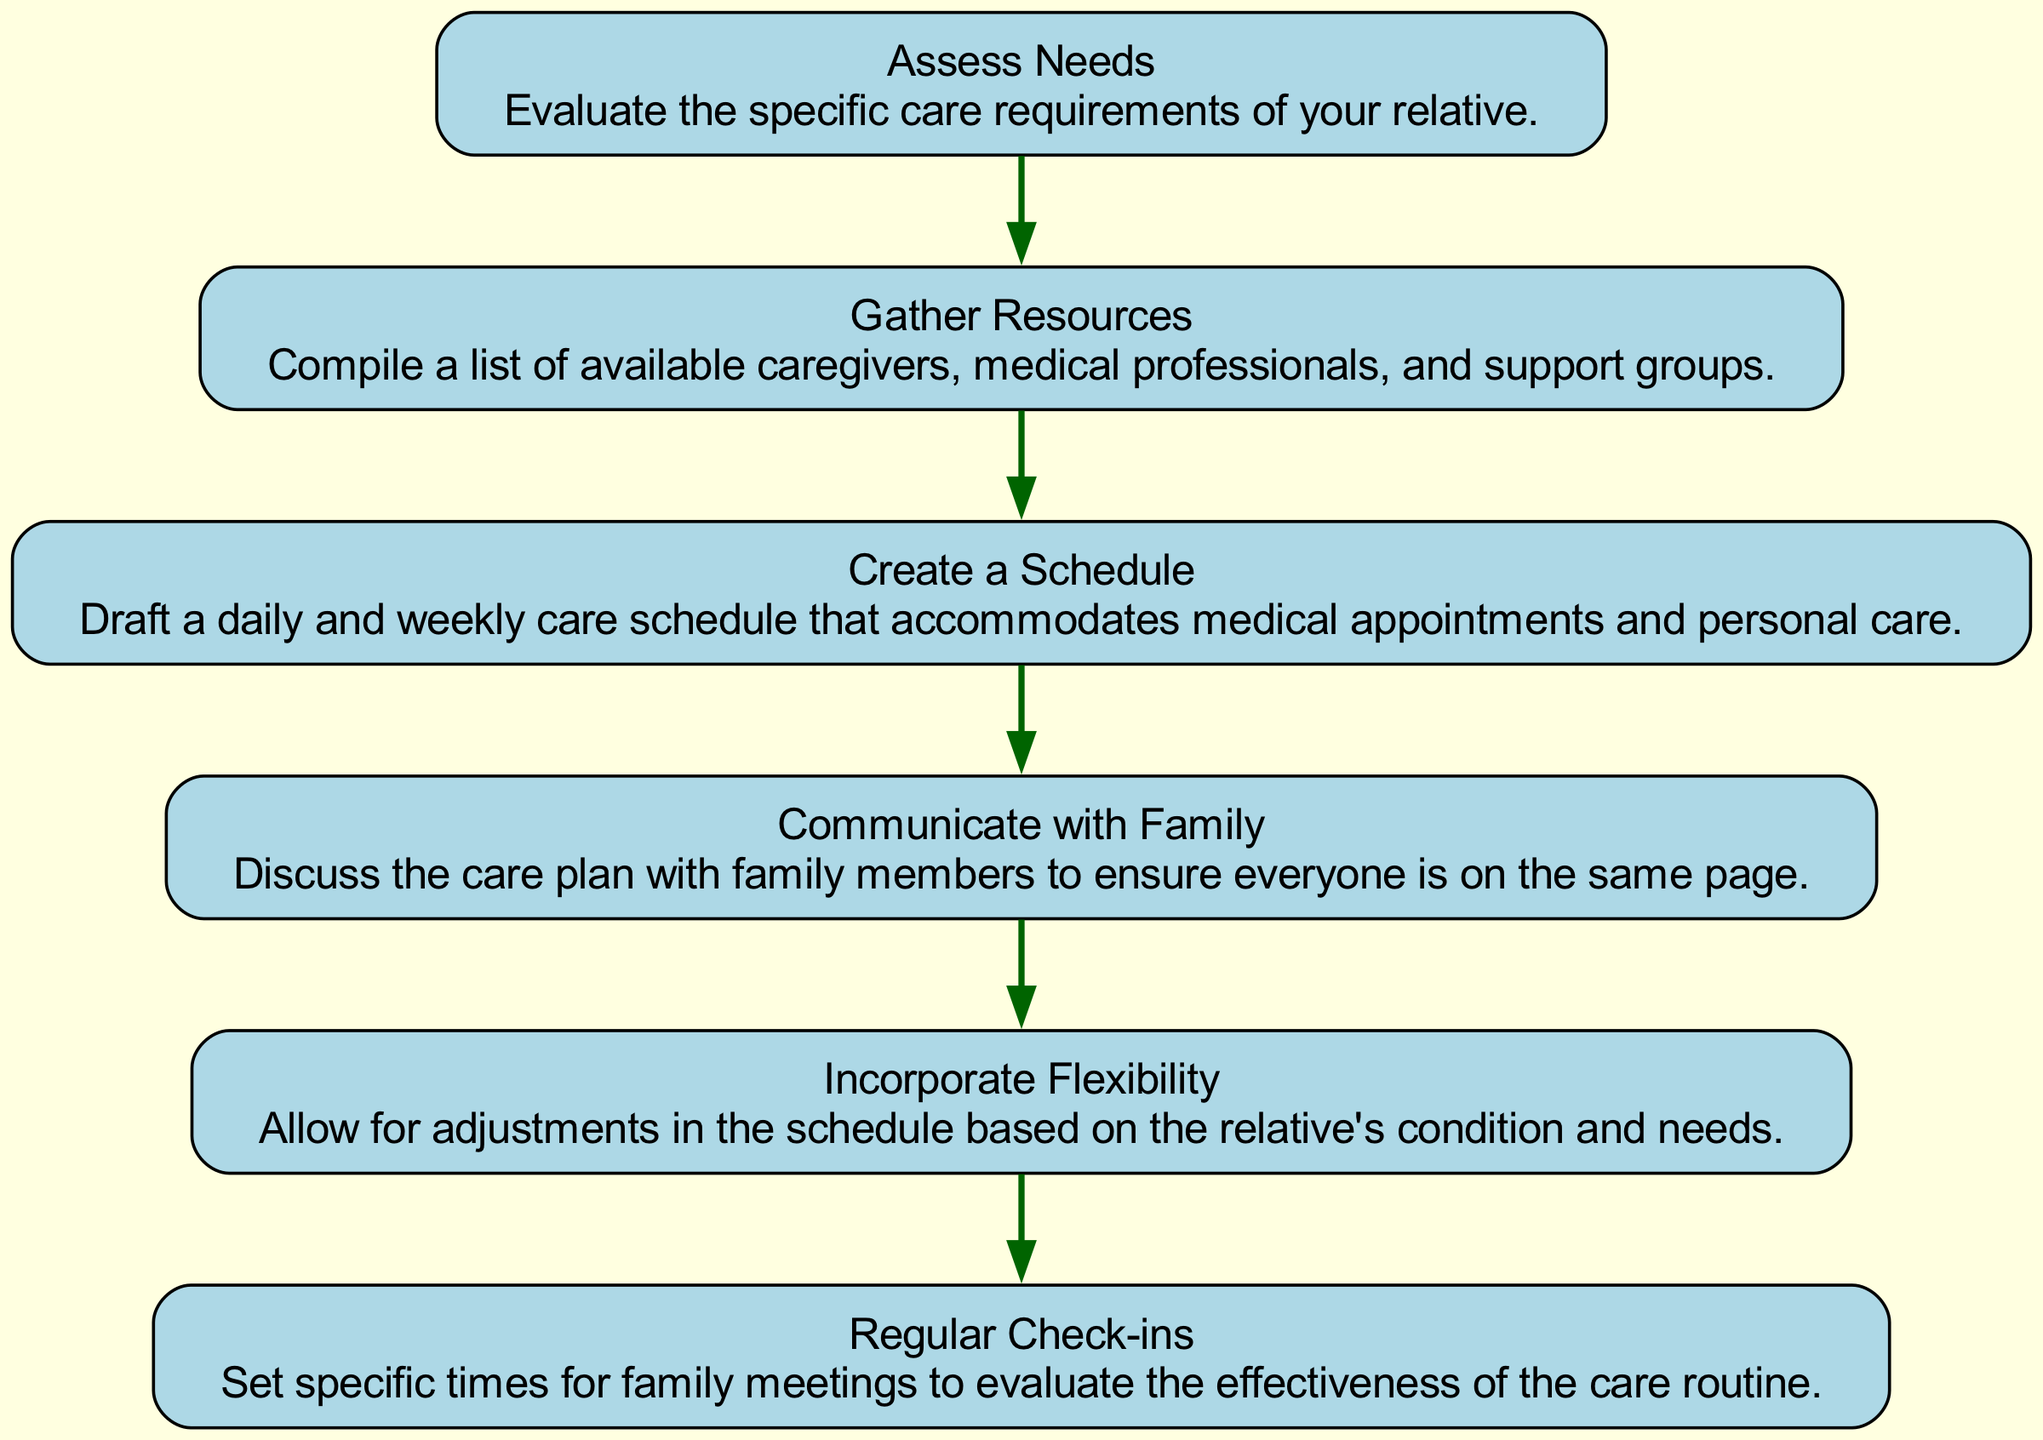What is the first step in the flow chart? The flow chart starts with the first step, which is "Assess Needs." This is indicated at the topmost part of the diagram.
Answer: Assess Needs How many steps are in the flow chart? By counting each of the listed steps in the diagram, there are a total of six steps provided.
Answer: Six What is the last step in the flow chart? The last step shown in the diagram is "Regular Check-ins," which is located at the bottom of the flow.
Answer: Regular Check-ins Which step comes after "Gather Resources"? After "Gather Resources," the next step in the flow chart is "Create a Schedule," as depicted by the directed edge connecting them.
Answer: Create a Schedule Why is "Incorporate Flexibility" an important step? "Incorporate Flexibility" is crucial because it highlights the need to adjust the schedule according to the relative's changing condition and needs, ensuring responsive care.
Answer: Adjust according to condition What is the relationship between "Create a Schedule" and "Communicate with Family"? "Create a Schedule" precedes "Communicate with Family" in the flow, indicating that the scheduling is discussed with family members after it's created to align on the care plan.
Answer: Scheduling to discussion How do steps relate to each other in this flow chart? In this flow chart, each step is sequentially linked by directed edges, showing a clear progression from assessing needs to regular evaluations of care.
Answer: Sequentially linked What do you do during "Regular Check-ins"? During "Regular Check-ins," family members evaluate the effectiveness of the care routine, allowing for necessary adjustments based on feedback.
Answer: Evaluate care routine effectiveness 